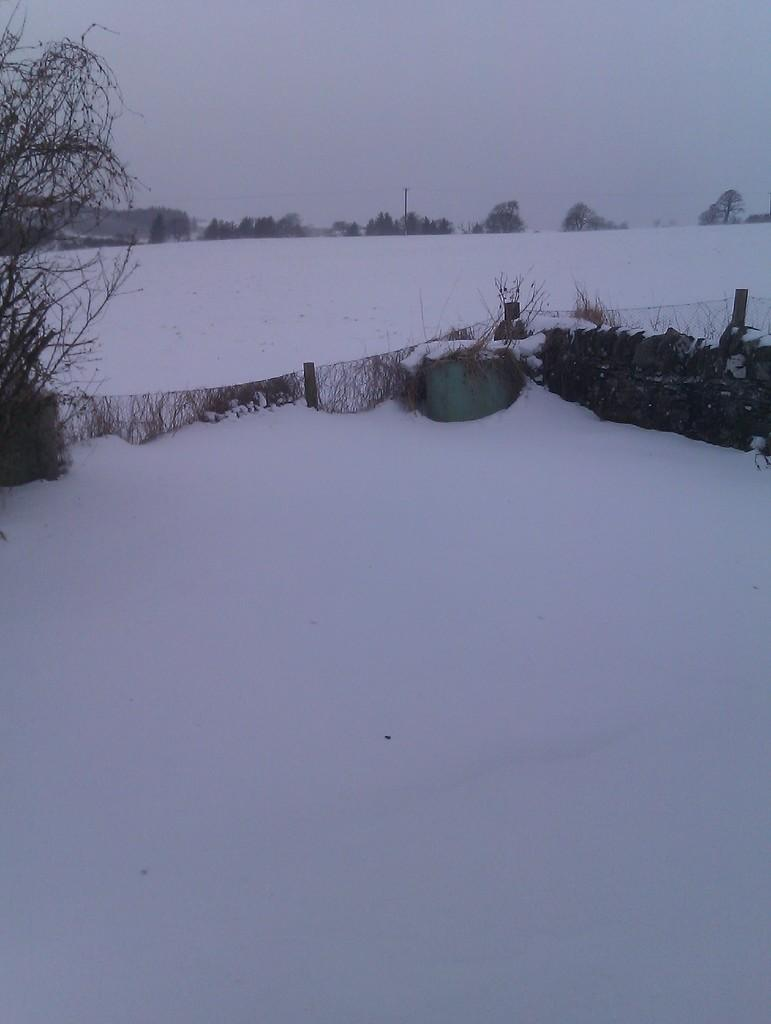What type of vegetation can be seen in the image? There are trees and plants in the image. What is covering the ground in the image? The ground is covered in snow. What structures are present in the image? There are poles in the image. What else can be found on the ground in the image? There are other objects on the ground. What is visible in the background of the image? The sky is visible in the background of the image. Can you tell me how many curtains are hanging from the trees in the image? There are no curtains hanging from the trees in the image; it features trees, plants, snow, poles, and other objects on the ground. How many legs are visible in the image? There are no legs visible in the image; it is a landscape scene with trees, plants, snow, poles, and other objects on the ground. 